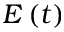<formula> <loc_0><loc_0><loc_500><loc_500>E \left ( t \right )</formula> 